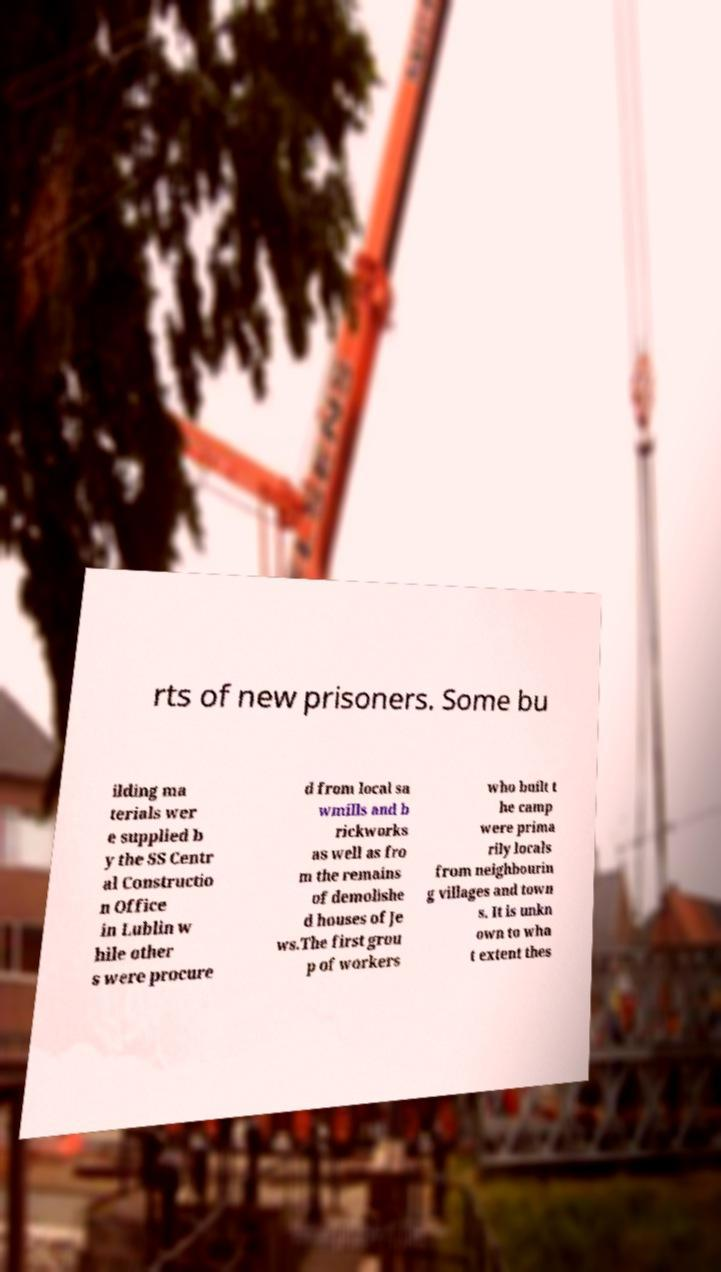Can you accurately transcribe the text from the provided image for me? rts of new prisoners. Some bu ilding ma terials wer e supplied b y the SS Centr al Constructio n Office in Lublin w hile other s were procure d from local sa wmills and b rickworks as well as fro m the remains of demolishe d houses of Je ws.The first grou p of workers who built t he camp were prima rily locals from neighbourin g villages and town s. It is unkn own to wha t extent thes 